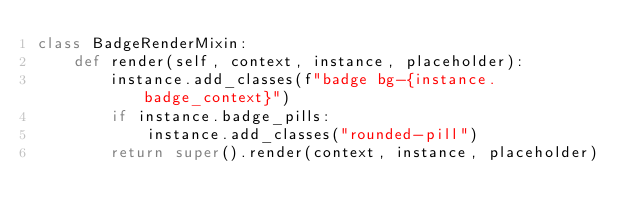<code> <loc_0><loc_0><loc_500><loc_500><_Python_>class BadgeRenderMixin:
    def render(self, context, instance, placeholder):
        instance.add_classes(f"badge bg-{instance.badge_context}")
        if instance.badge_pills:
            instance.add_classes("rounded-pill")
        return super().render(context, instance, placeholder)
</code> 